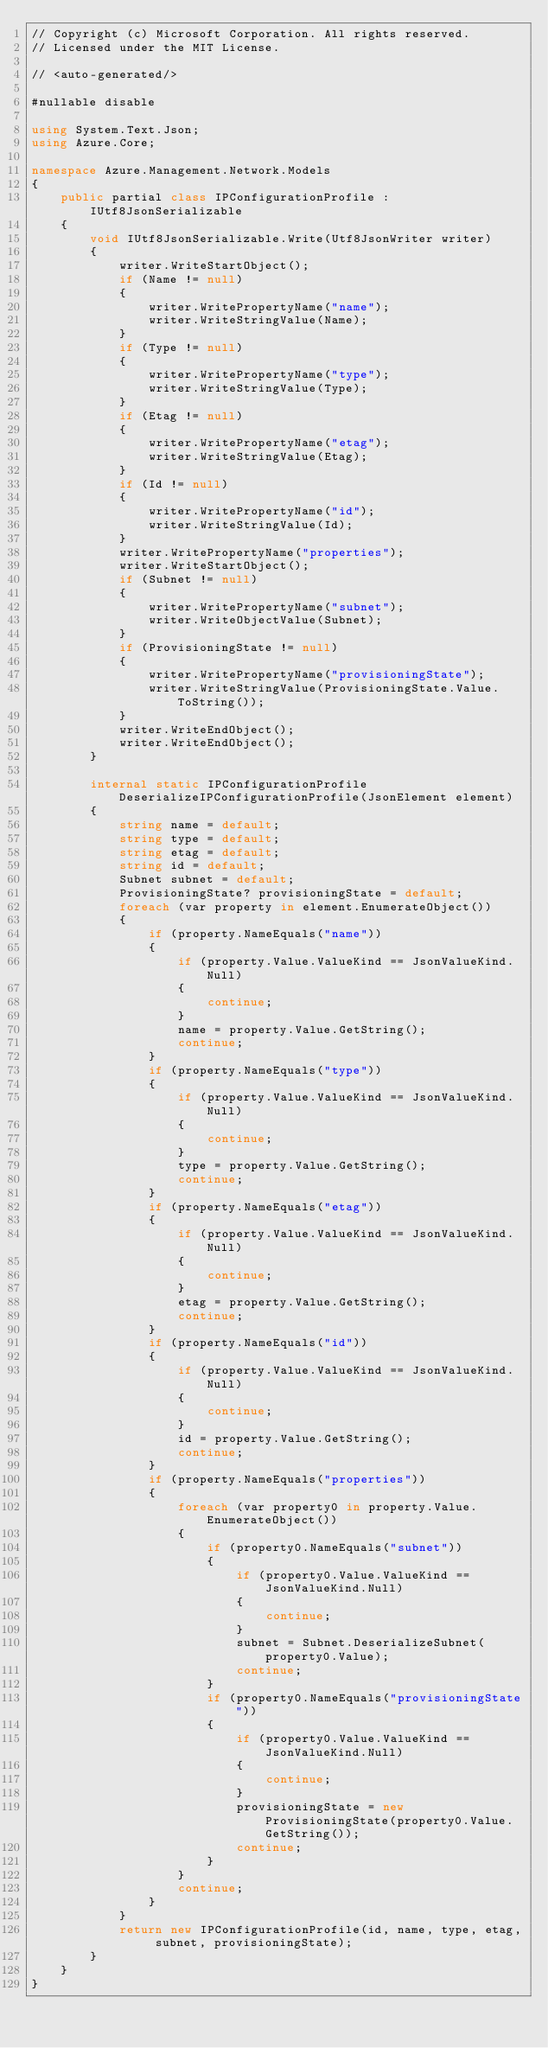Convert code to text. <code><loc_0><loc_0><loc_500><loc_500><_C#_>// Copyright (c) Microsoft Corporation. All rights reserved.
// Licensed under the MIT License.

// <auto-generated/>

#nullable disable

using System.Text.Json;
using Azure.Core;

namespace Azure.Management.Network.Models
{
    public partial class IPConfigurationProfile : IUtf8JsonSerializable
    {
        void IUtf8JsonSerializable.Write(Utf8JsonWriter writer)
        {
            writer.WriteStartObject();
            if (Name != null)
            {
                writer.WritePropertyName("name");
                writer.WriteStringValue(Name);
            }
            if (Type != null)
            {
                writer.WritePropertyName("type");
                writer.WriteStringValue(Type);
            }
            if (Etag != null)
            {
                writer.WritePropertyName("etag");
                writer.WriteStringValue(Etag);
            }
            if (Id != null)
            {
                writer.WritePropertyName("id");
                writer.WriteStringValue(Id);
            }
            writer.WritePropertyName("properties");
            writer.WriteStartObject();
            if (Subnet != null)
            {
                writer.WritePropertyName("subnet");
                writer.WriteObjectValue(Subnet);
            }
            if (ProvisioningState != null)
            {
                writer.WritePropertyName("provisioningState");
                writer.WriteStringValue(ProvisioningState.Value.ToString());
            }
            writer.WriteEndObject();
            writer.WriteEndObject();
        }

        internal static IPConfigurationProfile DeserializeIPConfigurationProfile(JsonElement element)
        {
            string name = default;
            string type = default;
            string etag = default;
            string id = default;
            Subnet subnet = default;
            ProvisioningState? provisioningState = default;
            foreach (var property in element.EnumerateObject())
            {
                if (property.NameEquals("name"))
                {
                    if (property.Value.ValueKind == JsonValueKind.Null)
                    {
                        continue;
                    }
                    name = property.Value.GetString();
                    continue;
                }
                if (property.NameEquals("type"))
                {
                    if (property.Value.ValueKind == JsonValueKind.Null)
                    {
                        continue;
                    }
                    type = property.Value.GetString();
                    continue;
                }
                if (property.NameEquals("etag"))
                {
                    if (property.Value.ValueKind == JsonValueKind.Null)
                    {
                        continue;
                    }
                    etag = property.Value.GetString();
                    continue;
                }
                if (property.NameEquals("id"))
                {
                    if (property.Value.ValueKind == JsonValueKind.Null)
                    {
                        continue;
                    }
                    id = property.Value.GetString();
                    continue;
                }
                if (property.NameEquals("properties"))
                {
                    foreach (var property0 in property.Value.EnumerateObject())
                    {
                        if (property0.NameEquals("subnet"))
                        {
                            if (property0.Value.ValueKind == JsonValueKind.Null)
                            {
                                continue;
                            }
                            subnet = Subnet.DeserializeSubnet(property0.Value);
                            continue;
                        }
                        if (property0.NameEquals("provisioningState"))
                        {
                            if (property0.Value.ValueKind == JsonValueKind.Null)
                            {
                                continue;
                            }
                            provisioningState = new ProvisioningState(property0.Value.GetString());
                            continue;
                        }
                    }
                    continue;
                }
            }
            return new IPConfigurationProfile(id, name, type, etag, subnet, provisioningState);
        }
    }
}
</code> 